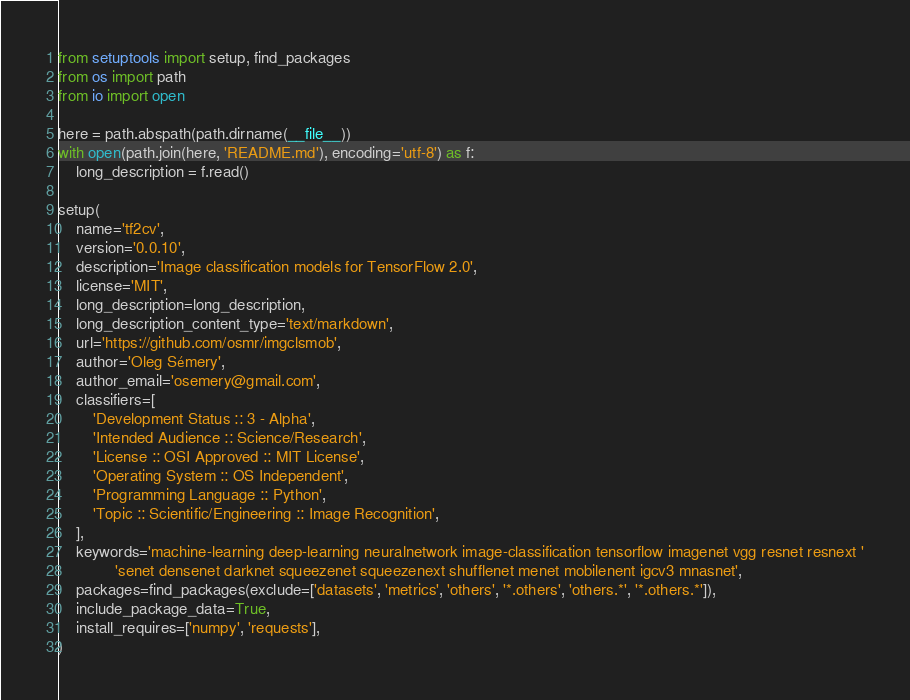<code> <loc_0><loc_0><loc_500><loc_500><_Python_>from setuptools import setup, find_packages
from os import path
from io import open

here = path.abspath(path.dirname(__file__))
with open(path.join(here, 'README.md'), encoding='utf-8') as f:
    long_description = f.read()

setup(
    name='tf2cv',
    version='0.0.10',
    description='Image classification models for TensorFlow 2.0',
    license='MIT',
    long_description=long_description,
    long_description_content_type='text/markdown',
    url='https://github.com/osmr/imgclsmob',
    author='Oleg Sémery',
    author_email='osemery@gmail.com',
    classifiers=[
        'Development Status :: 3 - Alpha',
        'Intended Audience :: Science/Research',
        'License :: OSI Approved :: MIT License',
        'Operating System :: OS Independent',
        'Programming Language :: Python',
        'Topic :: Scientific/Engineering :: Image Recognition',
    ],
    keywords='machine-learning deep-learning neuralnetwork image-classification tensorflow imagenet vgg resnet resnext '
             'senet densenet darknet squeezenet squeezenext shufflenet menet mobilenent igcv3 mnasnet',
    packages=find_packages(exclude=['datasets', 'metrics', 'others', '*.others', 'others.*', '*.others.*']),
    include_package_data=True,
    install_requires=['numpy', 'requests'],
)
</code> 